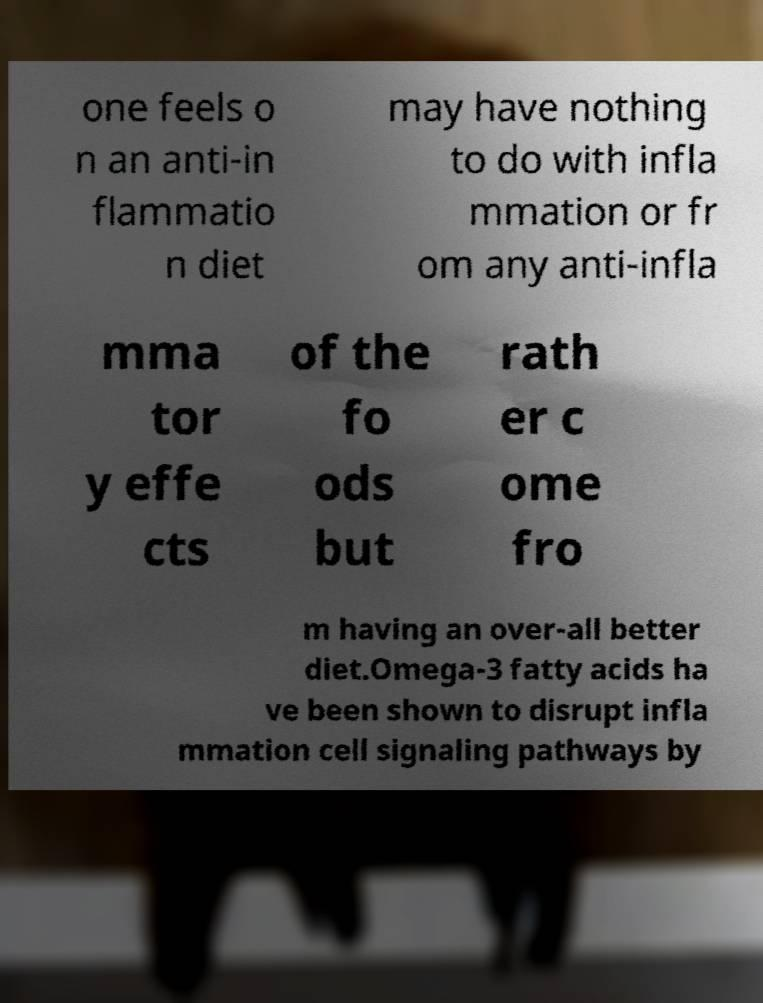Could you extract and type out the text from this image? one feels o n an anti-in flammatio n diet may have nothing to do with infla mmation or fr om any anti-infla mma tor y effe cts of the fo ods but rath er c ome fro m having an over-all better diet.Omega-3 fatty acids ha ve been shown to disrupt infla mmation cell signaling pathways by 